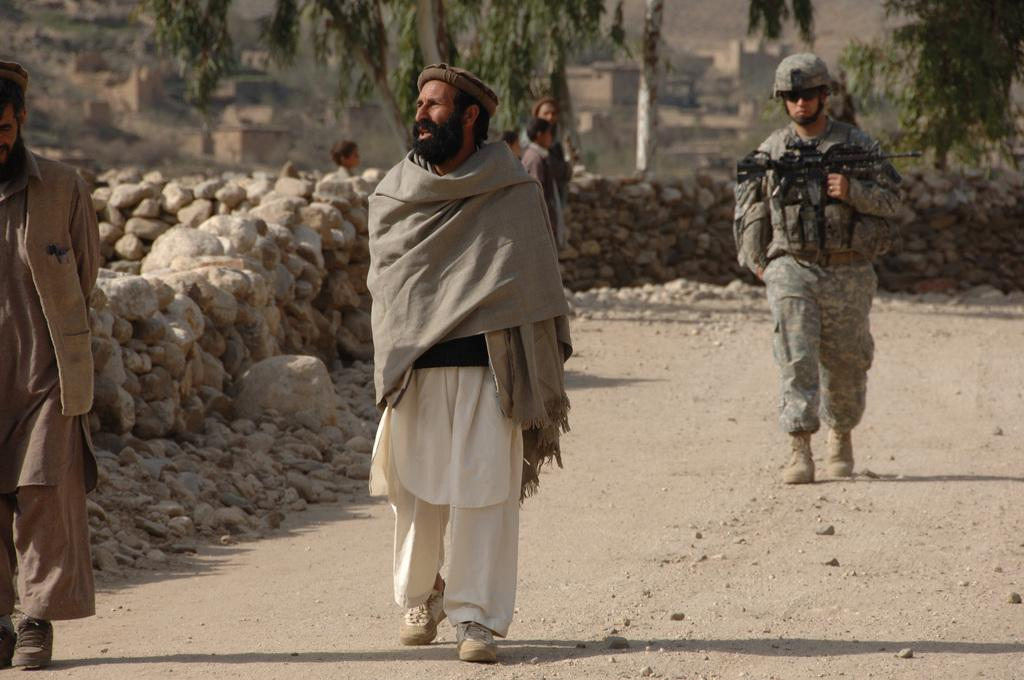What are the people in the image doing? The people in the image are walking on the road. What can be seen beside the road? There are rocks beside the road. What is visible in the background of the image? There are trees and buildings in the background of the image. How does the fog affect the visibility of the people walking on the road in the image? There is no fog present in the image, so it does not affect the visibility of the people walking on the road. 